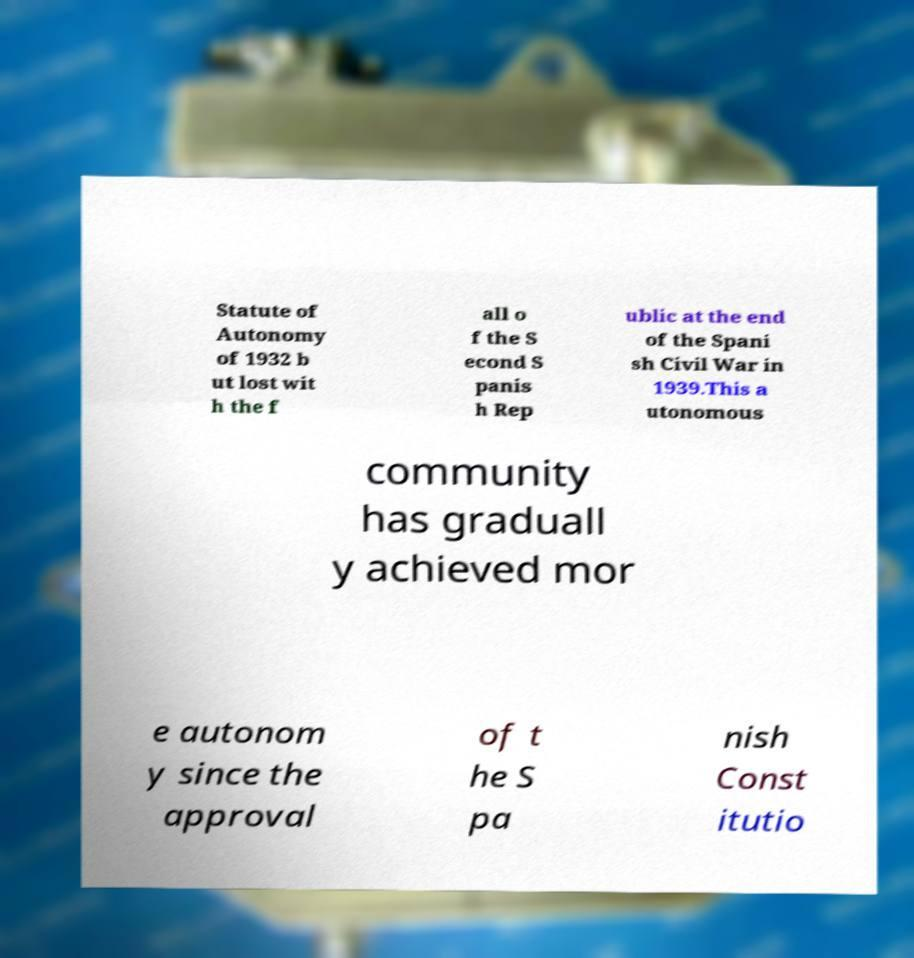I need the written content from this picture converted into text. Can you do that? Statute of Autonomy of 1932 b ut lost wit h the f all o f the S econd S panis h Rep ublic at the end of the Spani sh Civil War in 1939.This a utonomous community has graduall y achieved mor e autonom y since the approval of t he S pa nish Const itutio 